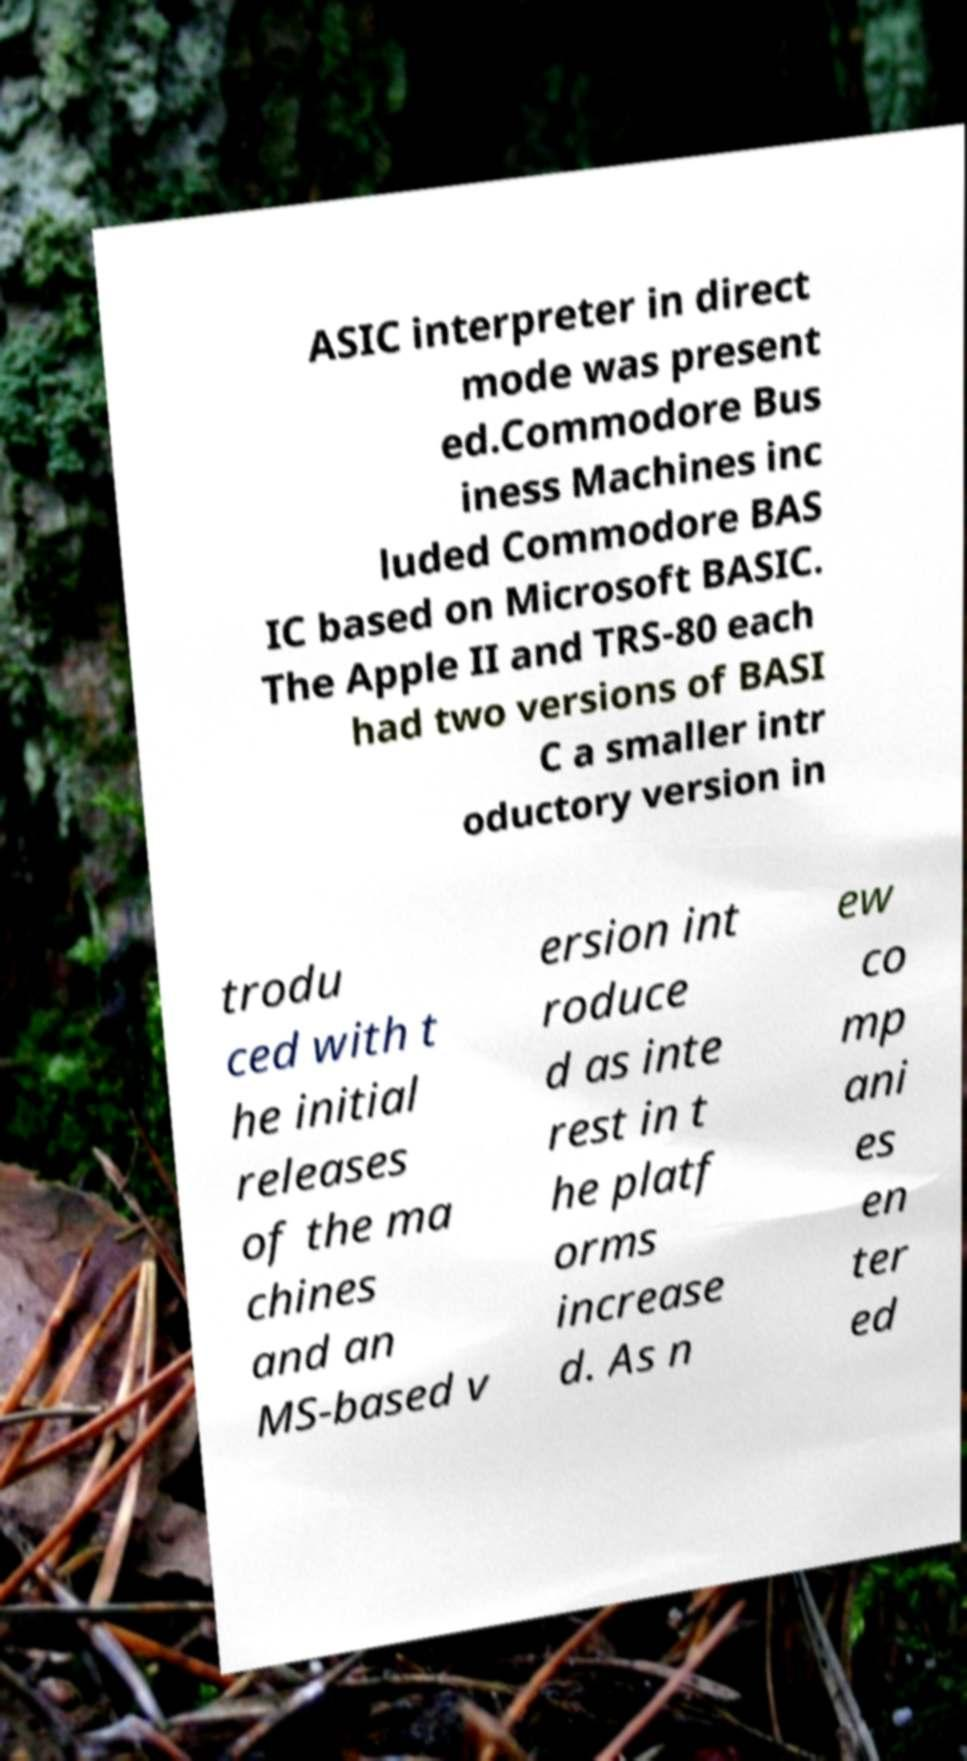I need the written content from this picture converted into text. Can you do that? ASIC interpreter in direct mode was present ed.Commodore Bus iness Machines inc luded Commodore BAS IC based on Microsoft BASIC. The Apple II and TRS-80 each had two versions of BASI C a smaller intr oductory version in trodu ced with t he initial releases of the ma chines and an MS-based v ersion int roduce d as inte rest in t he platf orms increase d. As n ew co mp ani es en ter ed 